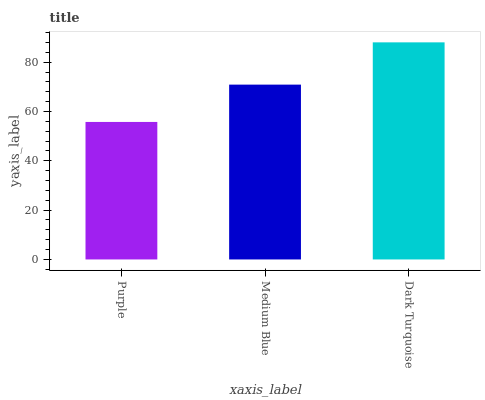Is Purple the minimum?
Answer yes or no. Yes. Is Dark Turquoise the maximum?
Answer yes or no. Yes. Is Medium Blue the minimum?
Answer yes or no. No. Is Medium Blue the maximum?
Answer yes or no. No. Is Medium Blue greater than Purple?
Answer yes or no. Yes. Is Purple less than Medium Blue?
Answer yes or no. Yes. Is Purple greater than Medium Blue?
Answer yes or no. No. Is Medium Blue less than Purple?
Answer yes or no. No. Is Medium Blue the high median?
Answer yes or no. Yes. Is Medium Blue the low median?
Answer yes or no. Yes. Is Dark Turquoise the high median?
Answer yes or no. No. Is Dark Turquoise the low median?
Answer yes or no. No. 